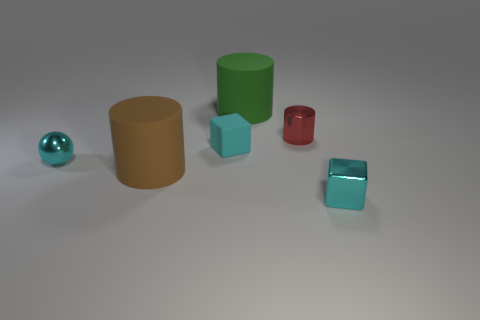Is there a cyan metallic block that is on the right side of the block to the right of the large green matte cylinder that is to the right of the cyan sphere? Yes, the cyan metallic block you are inquiring about is indeed located on the right side of another block, which is to the right of the large green matte cylinder, itself positioned to the right of the cyan sphere. 